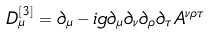Convert formula to latex. <formula><loc_0><loc_0><loc_500><loc_500>D ^ { [ 3 ] } _ { \mu } = \partial _ { \mu } - i g \partial _ { \mu } \partial _ { \nu } \partial _ { \rho } \partial _ { \tau } A ^ { \nu \rho \tau }</formula> 